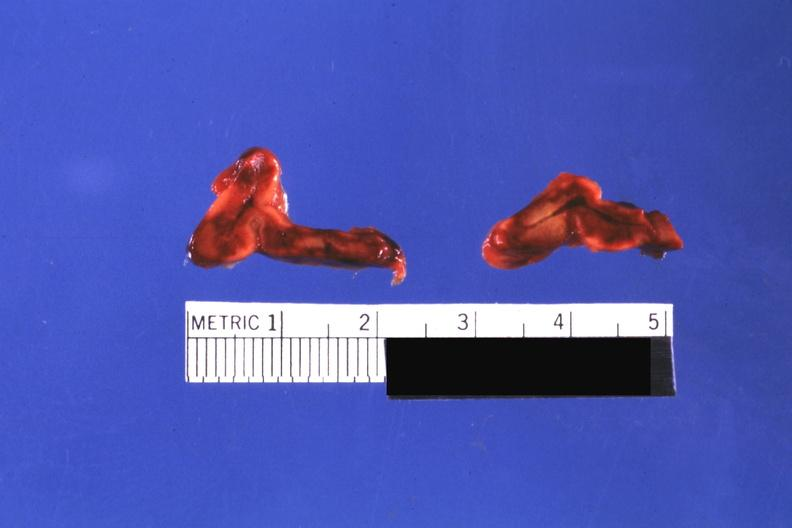s hemorrhage newborn present?
Answer the question using a single word or phrase. Yes 